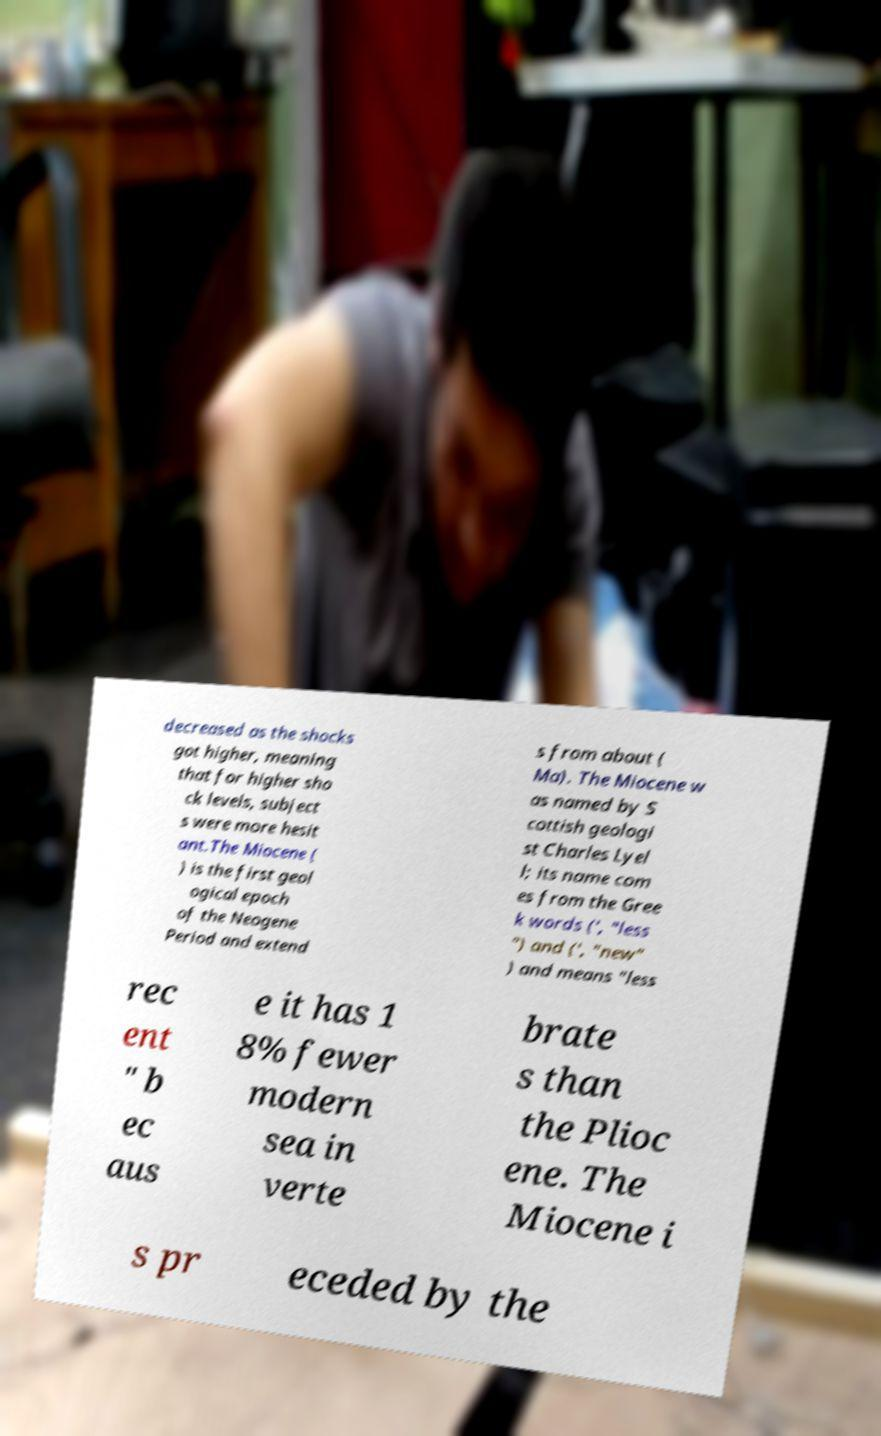Please identify and transcribe the text found in this image. decreased as the shocks got higher, meaning that for higher sho ck levels, subject s were more hesit ant.The Miocene ( ) is the first geol ogical epoch of the Neogene Period and extend s from about ( Ma). The Miocene w as named by S cottish geologi st Charles Lyel l; its name com es from the Gree k words (', "less ") and (', "new" ) and means "less rec ent " b ec aus e it has 1 8% fewer modern sea in verte brate s than the Plioc ene. The Miocene i s pr eceded by the 